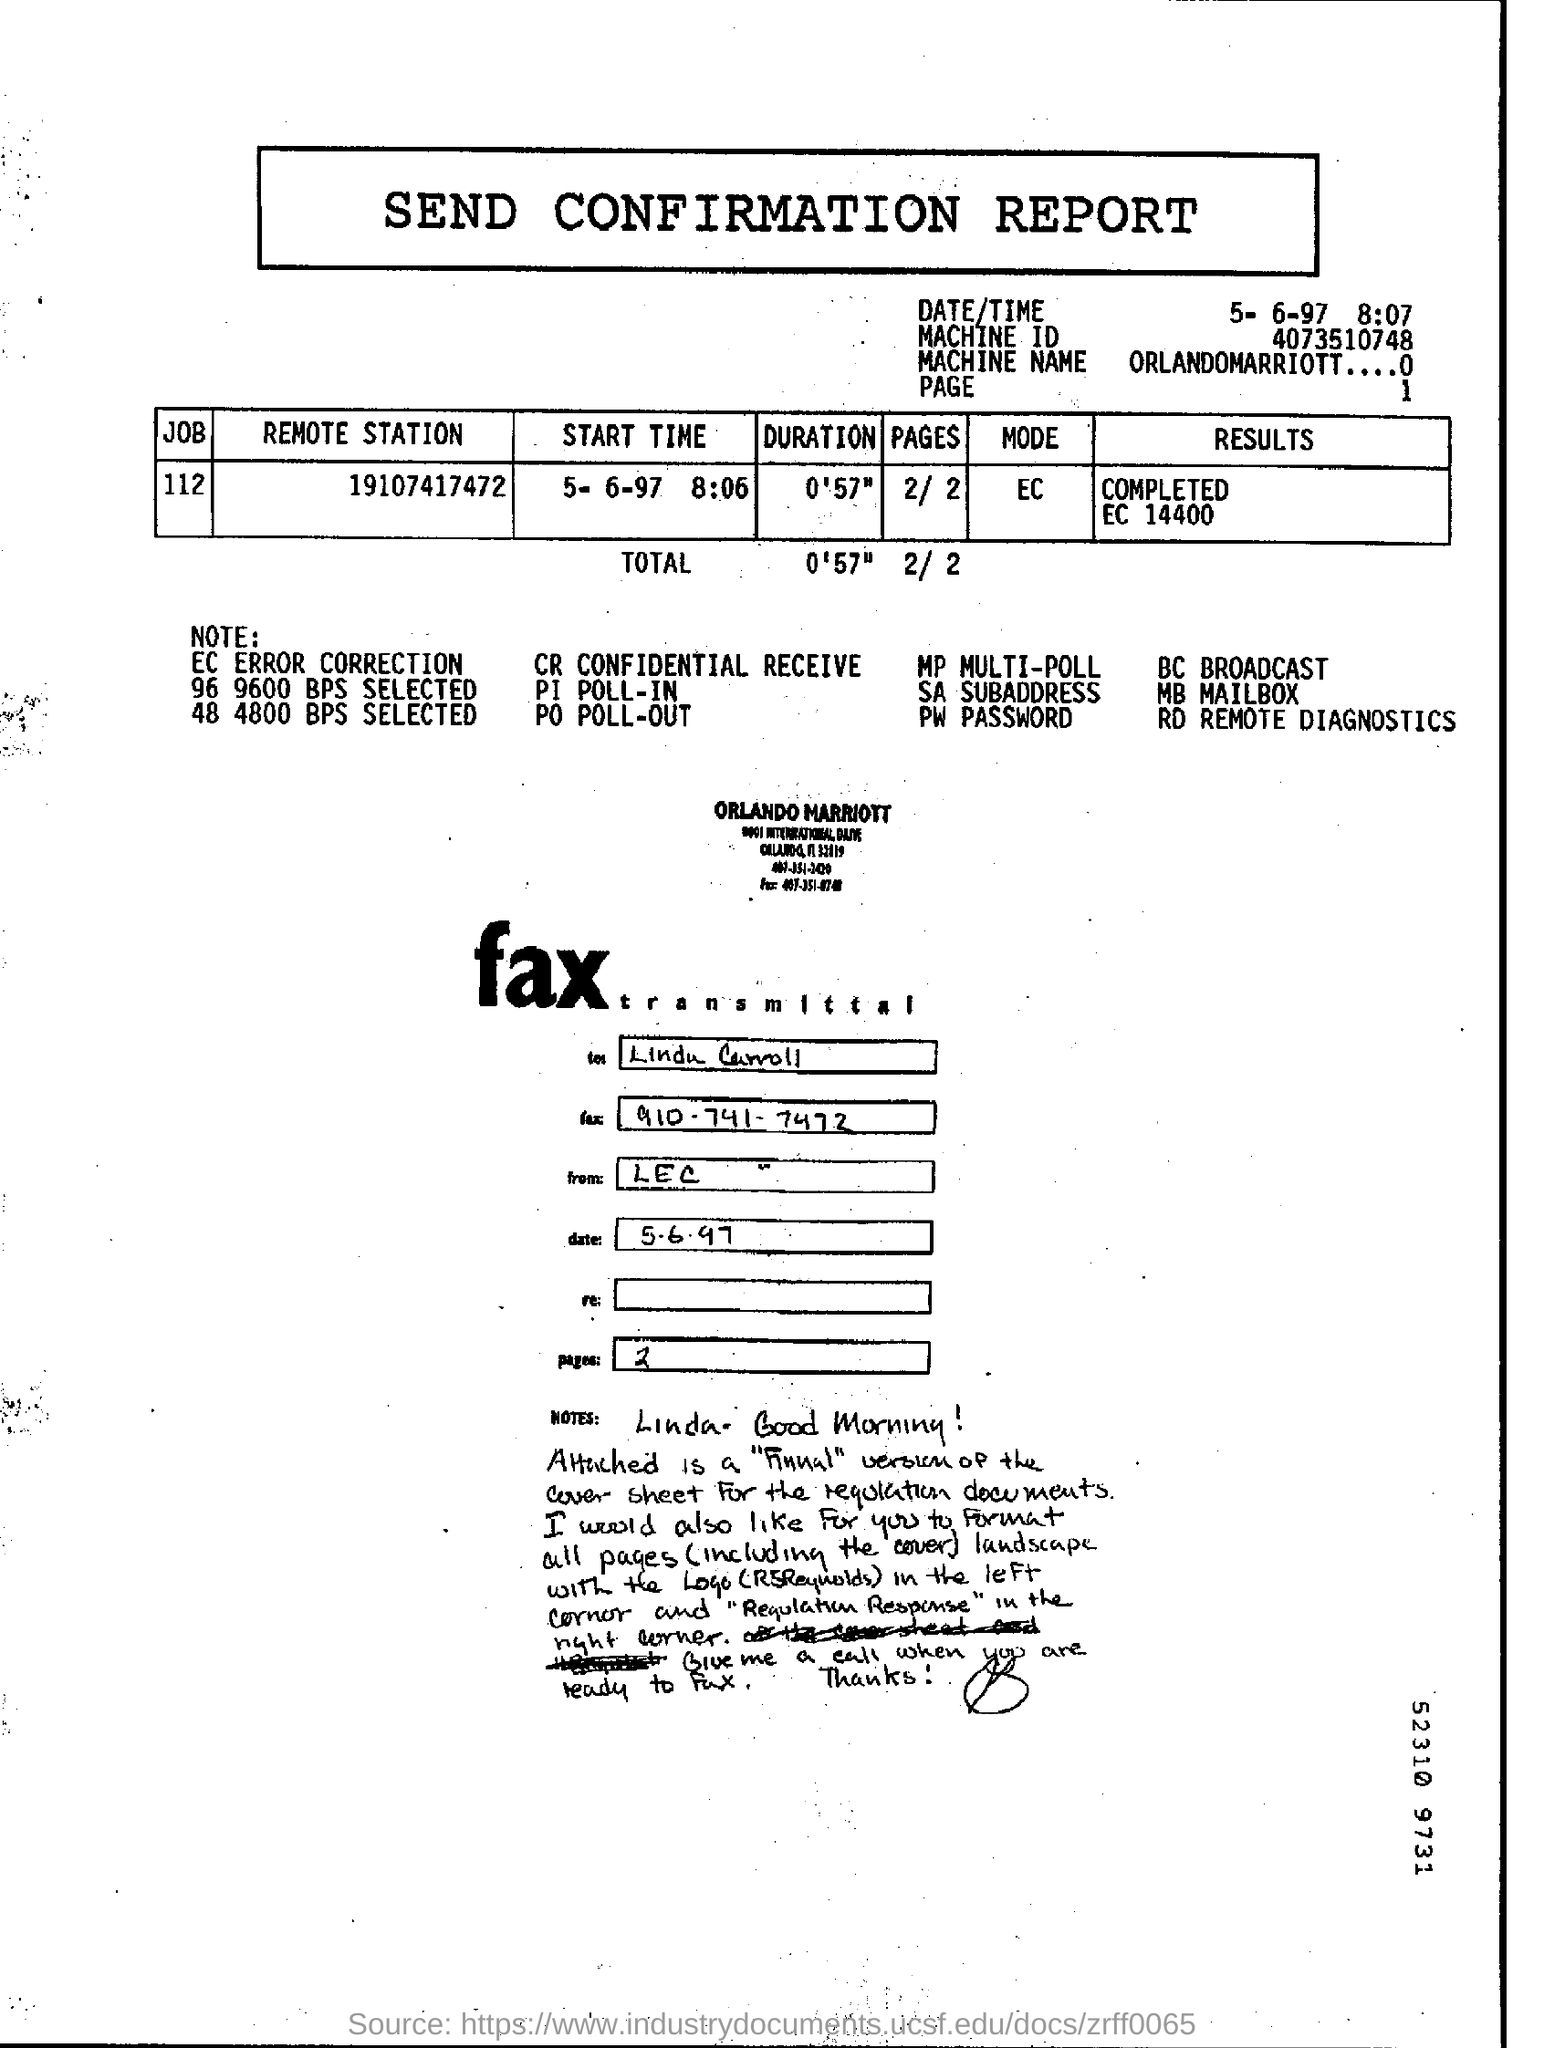What is the Machine ID mentioned in the  Send confirmation report?
Keep it short and to the point. 4073510748. What is the Machine Name given in the Send Confirmation report?
Make the answer very short. ORLANDOMARRIOTT....0. What is the Total duration mentioned in the report?
Give a very brief answer. 0'57". What is the Job no given in the  Send Confirmation report?
Provide a short and direct response. 112. What is the start time as per the report?
Give a very brief answer. 8:06. What is the FAX no mentioned in the fax transmittal?
Keep it short and to the point. 910-741-7472. 